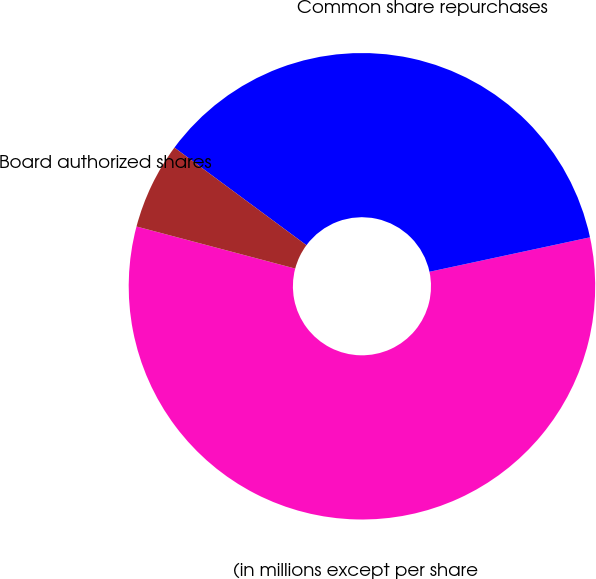Convert chart to OTSL. <chart><loc_0><loc_0><loc_500><loc_500><pie_chart><fcel>(in millions except per share<fcel>Common share repurchases<fcel>Board authorized shares<nl><fcel>57.49%<fcel>36.5%<fcel>6.01%<nl></chart> 